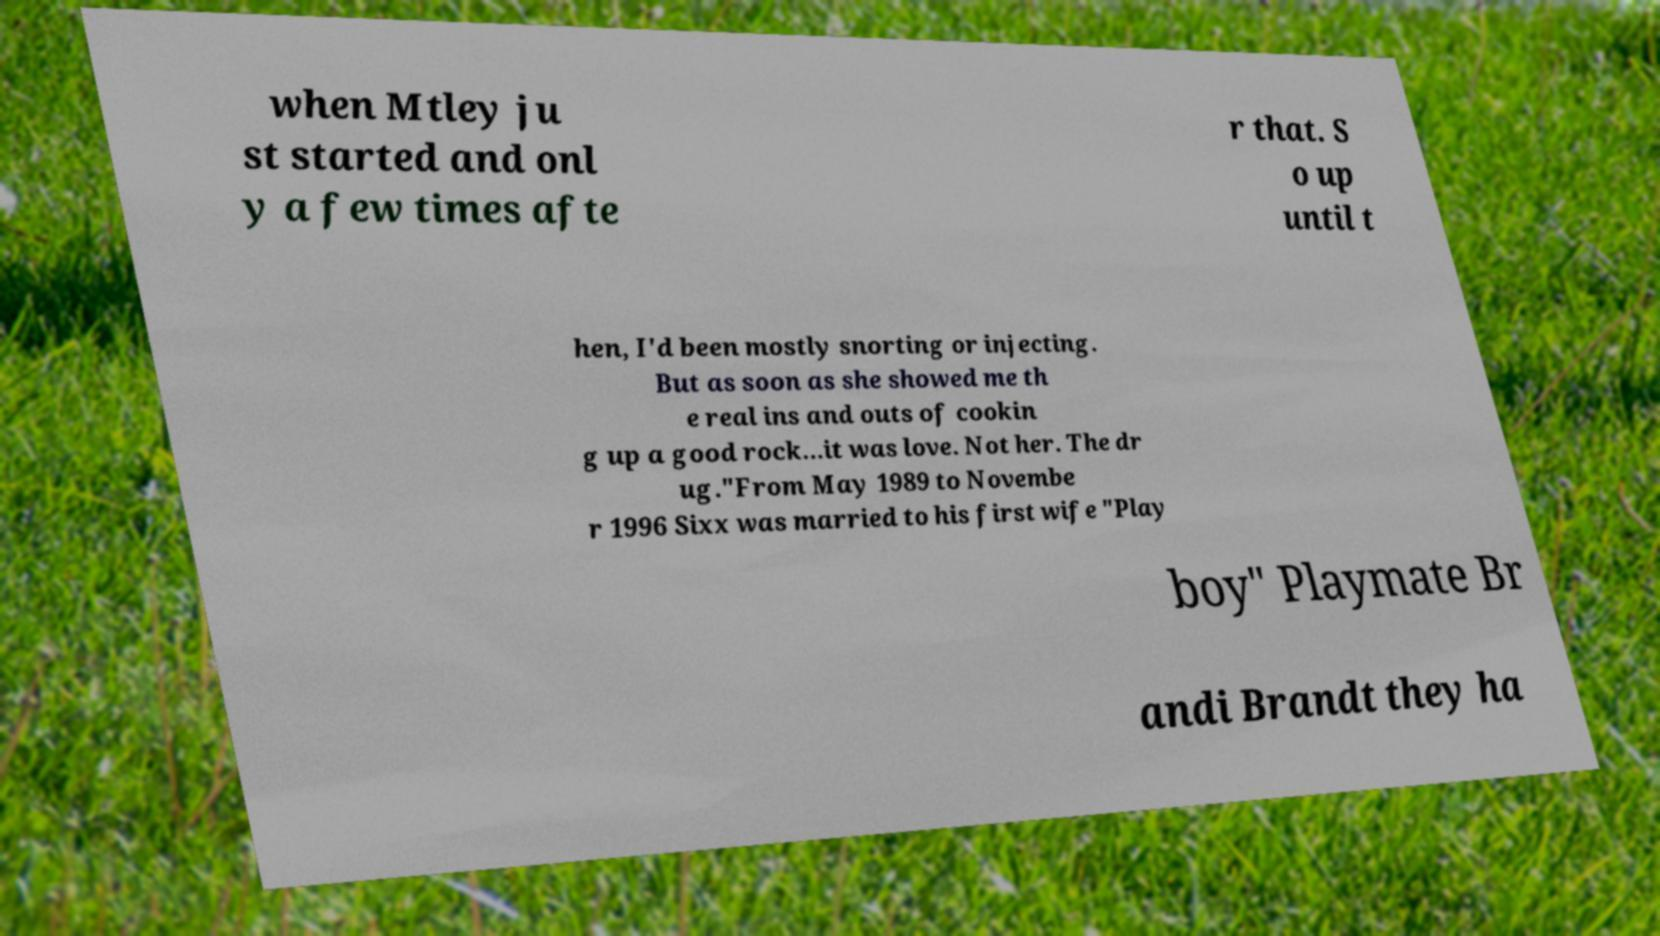For documentation purposes, I need the text within this image transcribed. Could you provide that? when Mtley ju st started and onl y a few times afte r that. S o up until t hen, I'd been mostly snorting or injecting. But as soon as she showed me th e real ins and outs of cookin g up a good rock…it was love. Not her. The dr ug."From May 1989 to Novembe r 1996 Sixx was married to his first wife "Play boy" Playmate Br andi Brandt they ha 